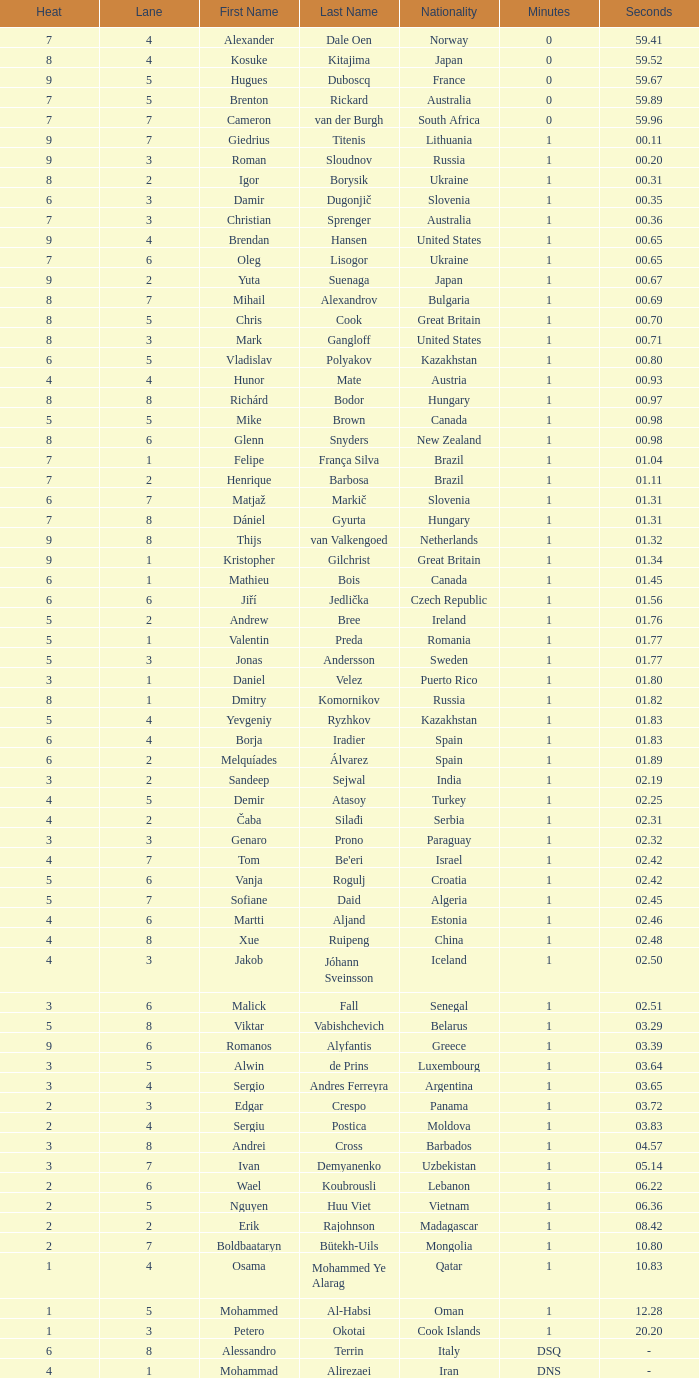What is the time in a heat smaller than 5, in Lane 5, for Vietnam? 1:06.36. 